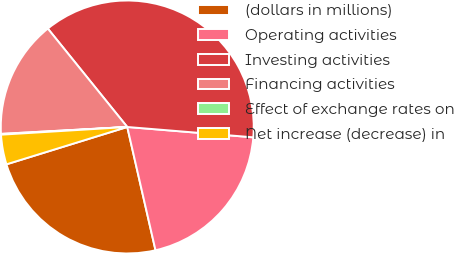Convert chart to OTSL. <chart><loc_0><loc_0><loc_500><loc_500><pie_chart><fcel>(dollars in millions)<fcel>Operating activities<fcel>Investing activities<fcel>Financing activities<fcel>Effect of exchange rates on<fcel>Net increase (decrease) in<nl><fcel>23.81%<fcel>20.11%<fcel>37.11%<fcel>15.06%<fcel>0.1%<fcel>3.8%<nl></chart> 